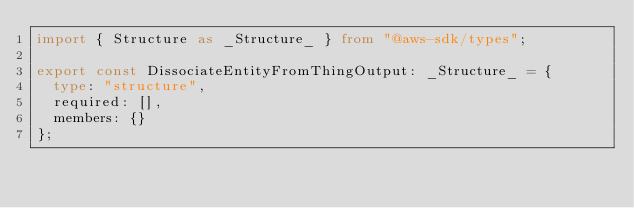Convert code to text. <code><loc_0><loc_0><loc_500><loc_500><_TypeScript_>import { Structure as _Structure_ } from "@aws-sdk/types";

export const DissociateEntityFromThingOutput: _Structure_ = {
  type: "structure",
  required: [],
  members: {}
};
</code> 